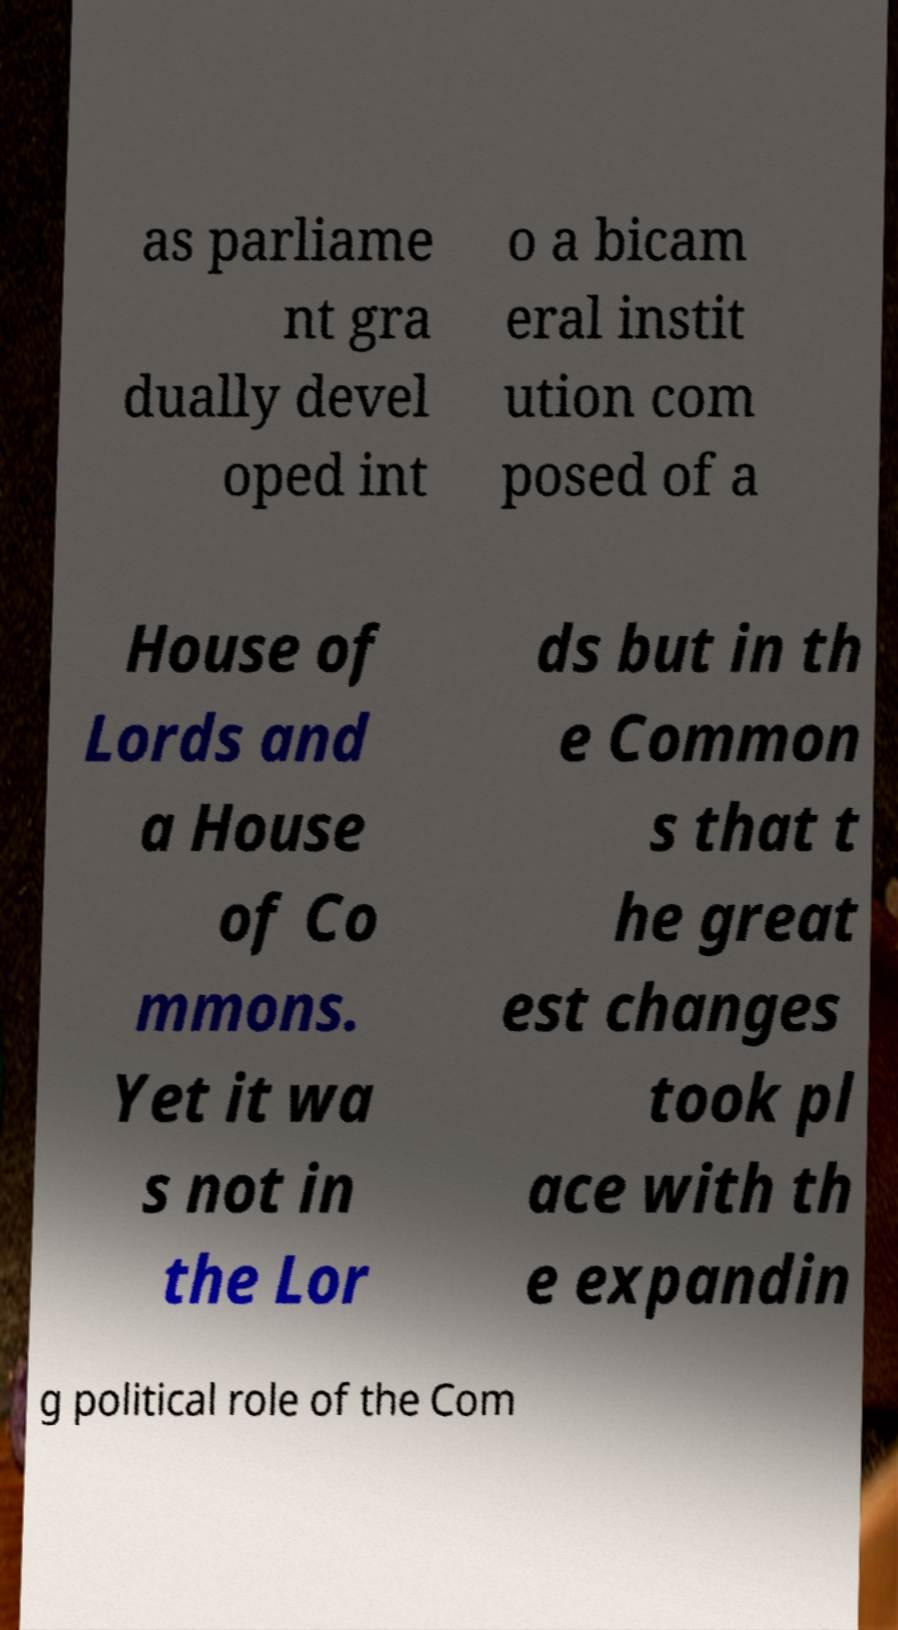For documentation purposes, I need the text within this image transcribed. Could you provide that? as parliame nt gra dually devel oped int o a bicam eral instit ution com posed of a House of Lords and a House of Co mmons. Yet it wa s not in the Lor ds but in th e Common s that t he great est changes took pl ace with th e expandin g political role of the Com 